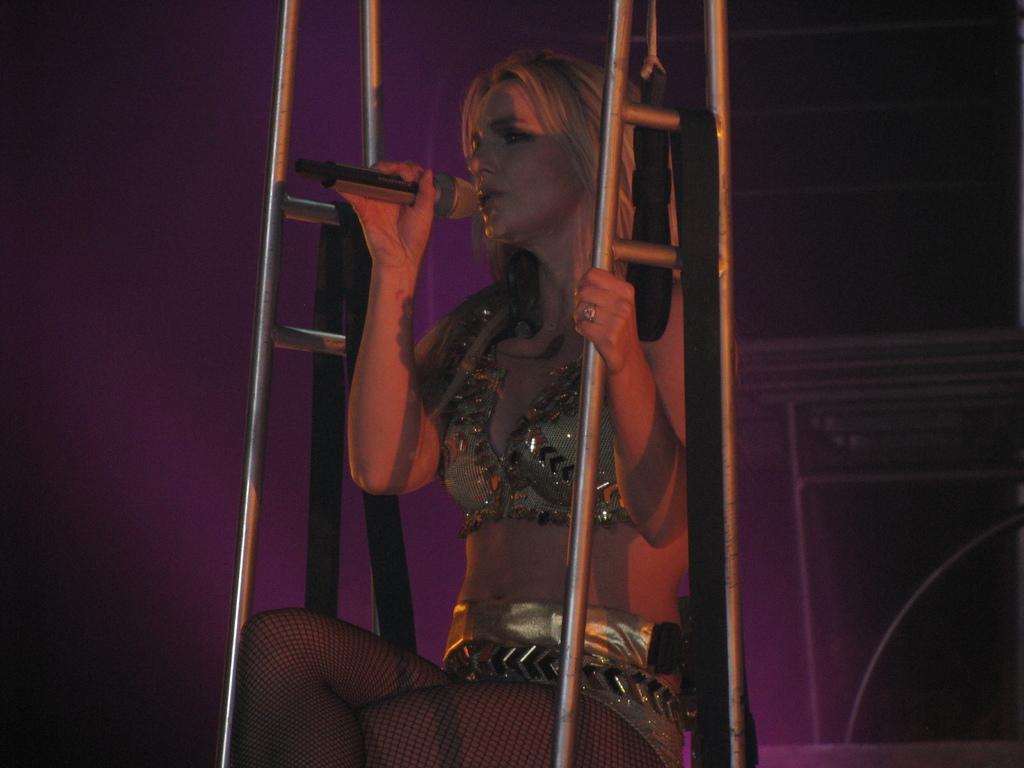Describe this image in one or two sentences. In this image we can see a woman is sitting and holding a mic in her hand and there are stands to the left and right side to her and she is holding the stand with the another hand and there are clothes on the stands. In the background the image is not clear but we can see objects. 